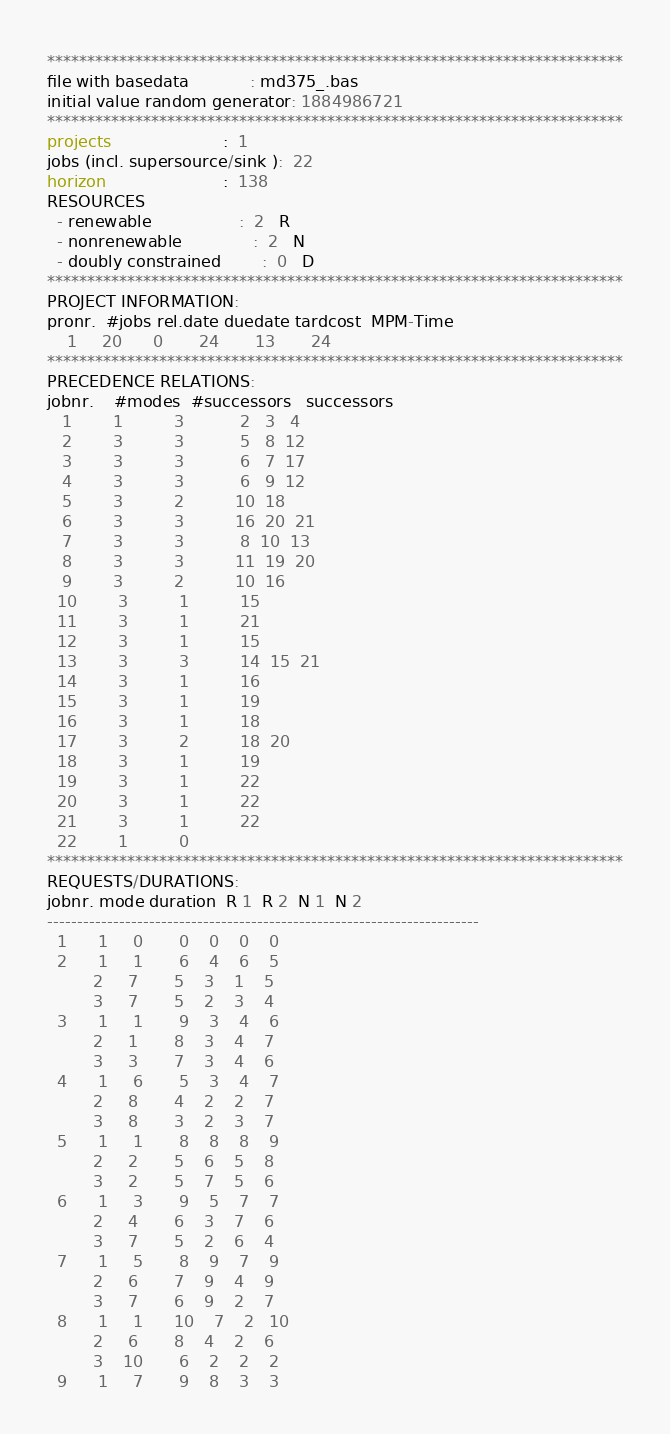<code> <loc_0><loc_0><loc_500><loc_500><_ObjectiveC_>************************************************************************
file with basedata            : md375_.bas
initial value random generator: 1884986721
************************************************************************
projects                      :  1
jobs (incl. supersource/sink ):  22
horizon                       :  138
RESOURCES
  - renewable                 :  2   R
  - nonrenewable              :  2   N
  - doubly constrained        :  0   D
************************************************************************
PROJECT INFORMATION:
pronr.  #jobs rel.date duedate tardcost  MPM-Time
    1     20      0       24       13       24
************************************************************************
PRECEDENCE RELATIONS:
jobnr.    #modes  #successors   successors
   1        1          3           2   3   4
   2        3          3           5   8  12
   3        3          3           6   7  17
   4        3          3           6   9  12
   5        3          2          10  18
   6        3          3          16  20  21
   7        3          3           8  10  13
   8        3          3          11  19  20
   9        3          2          10  16
  10        3          1          15
  11        3          1          21
  12        3          1          15
  13        3          3          14  15  21
  14        3          1          16
  15        3          1          19
  16        3          1          18
  17        3          2          18  20
  18        3          1          19
  19        3          1          22
  20        3          1          22
  21        3          1          22
  22        1          0        
************************************************************************
REQUESTS/DURATIONS:
jobnr. mode duration  R 1  R 2  N 1  N 2
------------------------------------------------------------------------
  1      1     0       0    0    0    0
  2      1     1       6    4    6    5
         2     7       5    3    1    5
         3     7       5    2    3    4
  3      1     1       9    3    4    6
         2     1       8    3    4    7
         3     3       7    3    4    6
  4      1     6       5    3    4    7
         2     8       4    2    2    7
         3     8       3    2    3    7
  5      1     1       8    8    8    9
         2     2       5    6    5    8
         3     2       5    7    5    6
  6      1     3       9    5    7    7
         2     4       6    3    7    6
         3     7       5    2    6    4
  7      1     5       8    9    7    9
         2     6       7    9    4    9
         3     7       6    9    2    7
  8      1     1      10    7    2   10
         2     6       8    4    2    6
         3    10       6    2    2    2
  9      1     7       9    8    3    3</code> 